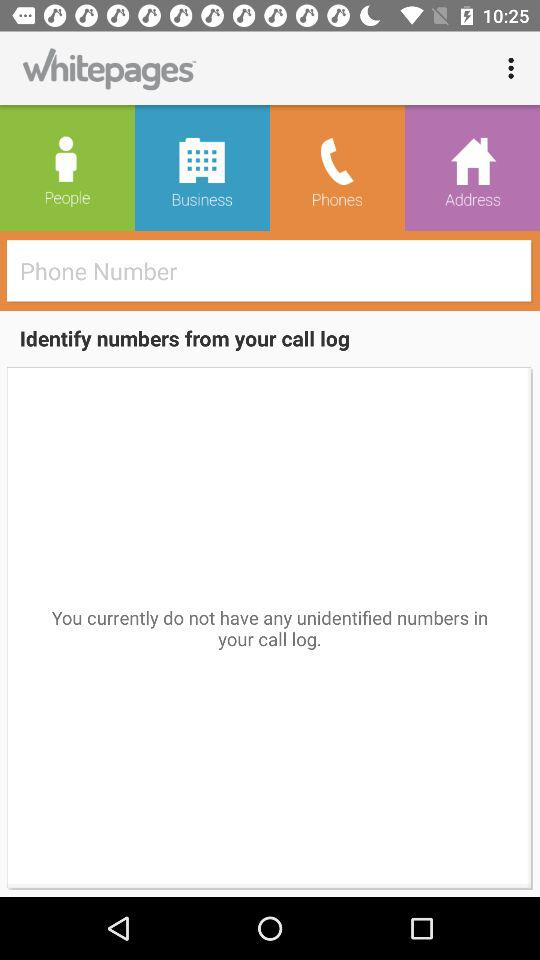How many numbers have not been identified?
Answer the question using a single word or phrase. 0 